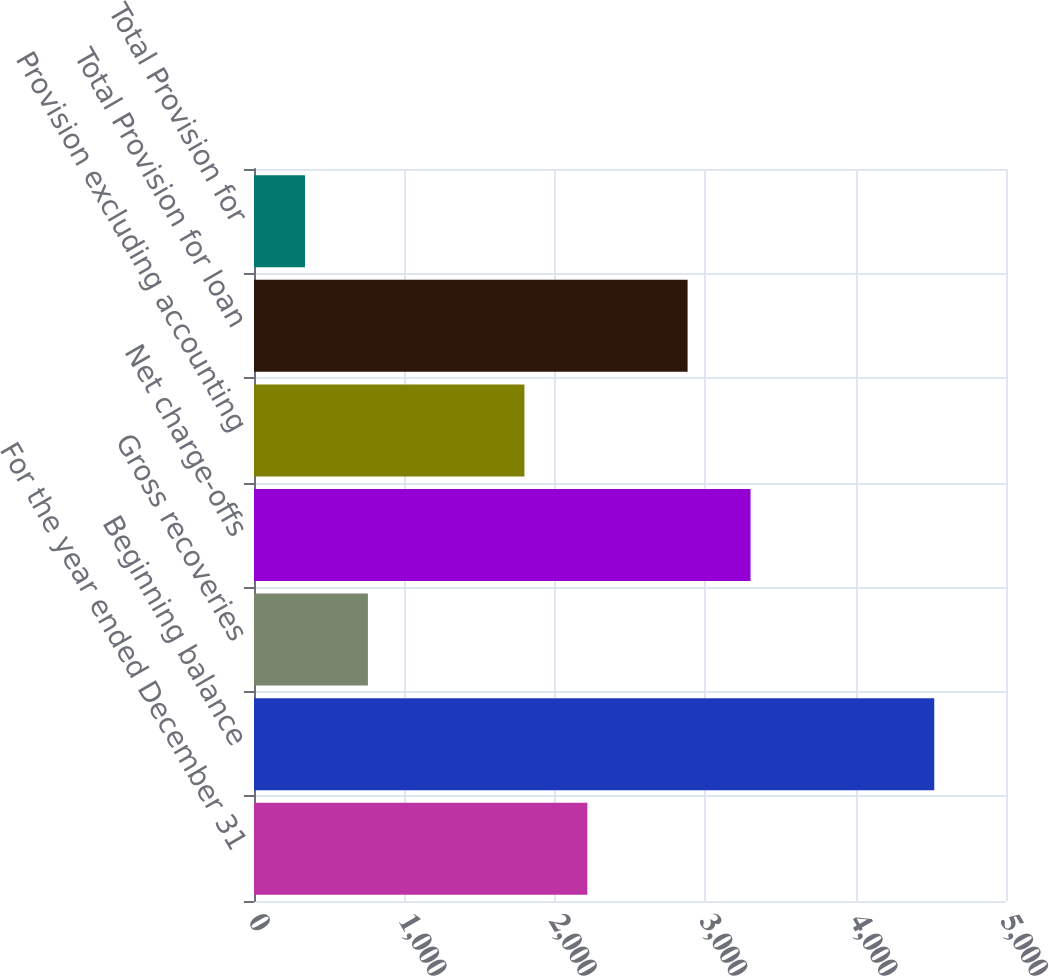<chart> <loc_0><loc_0><loc_500><loc_500><bar_chart><fcel>For the year ended December 31<fcel>Beginning balance<fcel>Gross recoveries<fcel>Net charge-offs<fcel>Provision excluding accounting<fcel>Total Provision for loan<fcel>Total Provision for<nl><fcel>2216.4<fcel>4523<fcel>757.4<fcel>3301.4<fcel>1798<fcel>2883<fcel>339<nl></chart> 